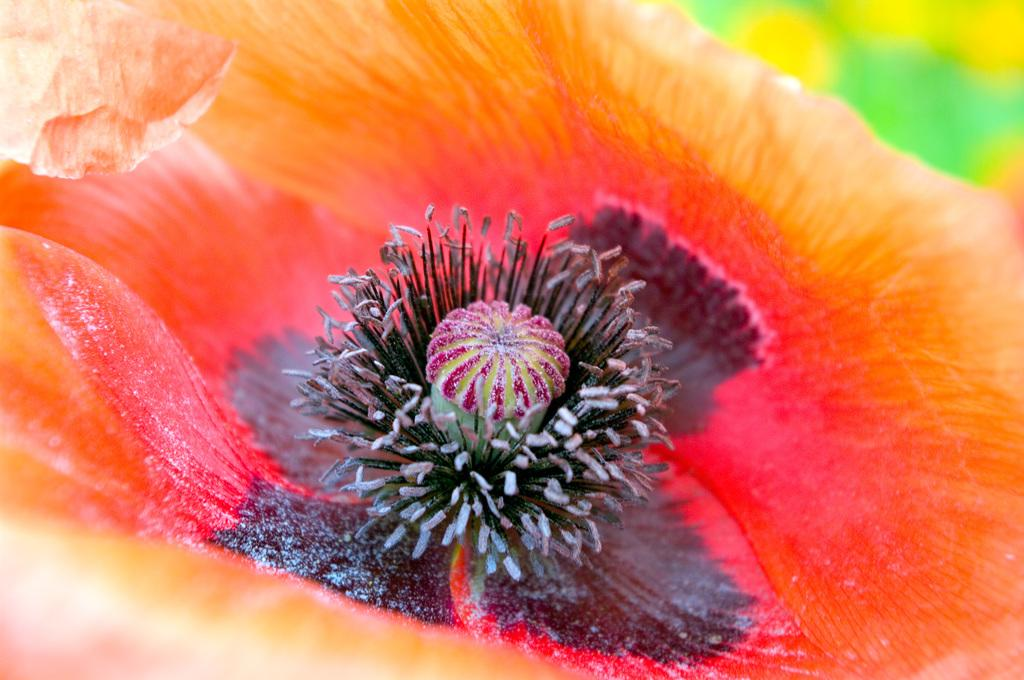What is the main subject of the image? The main subject of the image is a flower. Can you describe the flower's appearance? The flower has buds and its color includes orange, red, and black. What type of advertisement is displayed on the glove in the image? There is no glove or advertisement present in the image; it features a flower with buds and a specific color combination. 